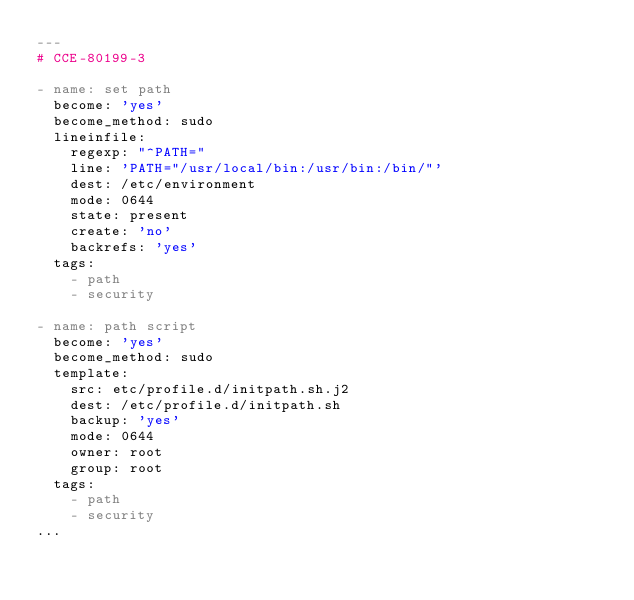Convert code to text. <code><loc_0><loc_0><loc_500><loc_500><_YAML_>---
# CCE-80199-3

- name: set path
  become: 'yes'
  become_method: sudo
  lineinfile:
    regexp: "^PATH="
    line: 'PATH="/usr/local/bin:/usr/bin:/bin/"'
    dest: /etc/environment
    mode: 0644
    state: present
    create: 'no'
    backrefs: 'yes'
  tags:
    - path
    - security

- name: path script
  become: 'yes'
  become_method: sudo
  template:
    src: etc/profile.d/initpath.sh.j2
    dest: /etc/profile.d/initpath.sh
    backup: 'yes'
    mode: 0644
    owner: root
    group: root
  tags:
    - path
    - security
...
</code> 